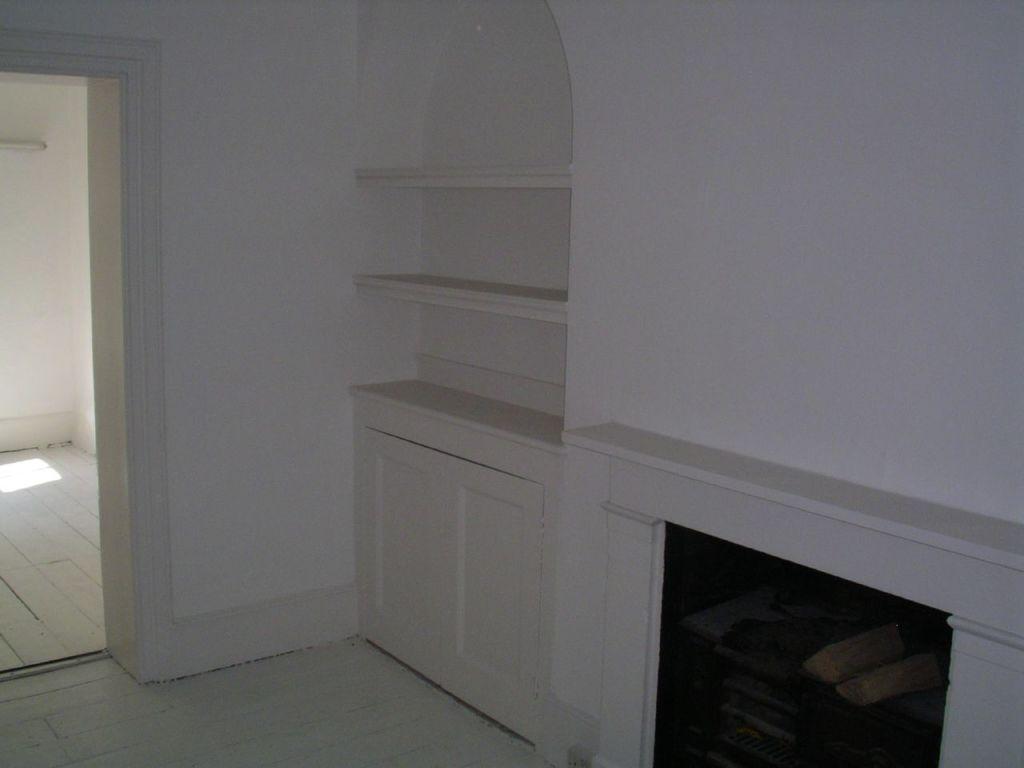In one or two sentences, can you explain what this image depicts? In this image I can see wall in white color. I can also see few shelves. 